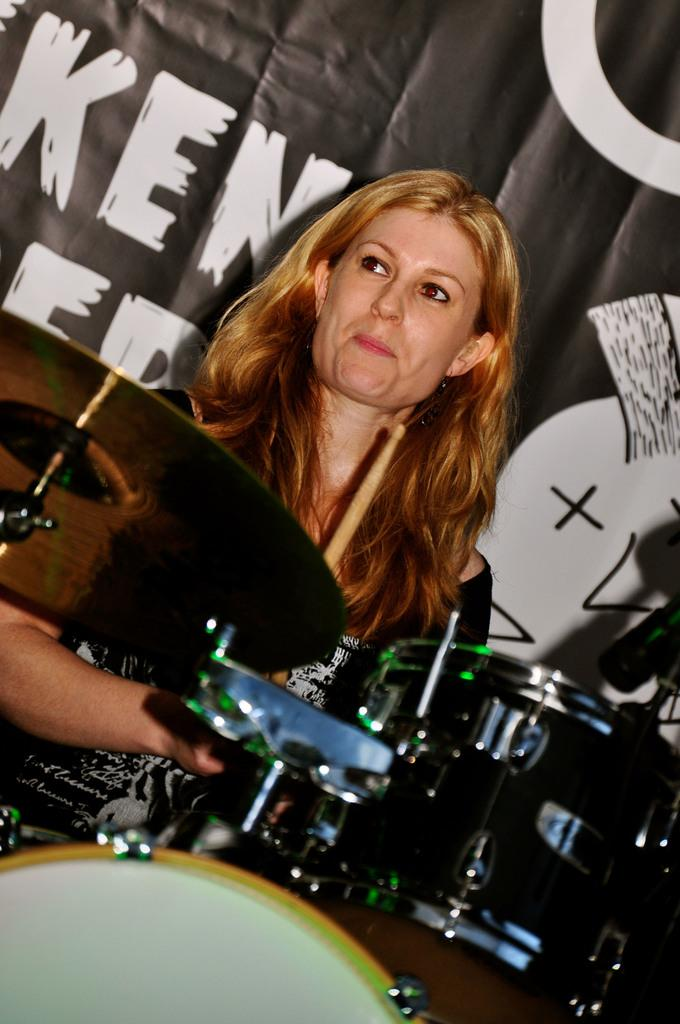Who is the main subject in the image? There is a lady person in the image. What is the lady person wearing? The lady person is wearing a black dress. What is the lady person doing in the image? The lady person is beating drums. What is the value of the necklace worn by the lady person in the image? There is no necklace visible in the image, so it is not possible to determine its value. 